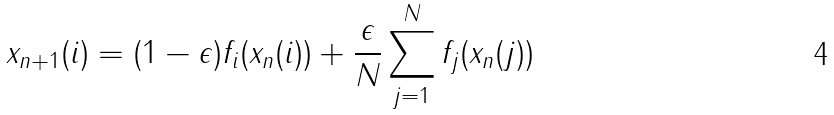Convert formula to latex. <formula><loc_0><loc_0><loc_500><loc_500>x _ { n + 1 } ( i ) = ( 1 - \epsilon ) f _ { i } ( x _ { n } ( i ) ) + \frac { \epsilon } { N } \sum _ { j = 1 } ^ { N } f _ { j } ( x _ { n } ( j ) )</formula> 